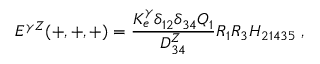Convert formula to latex. <formula><loc_0><loc_0><loc_500><loc_500>E ^ { \gamma Z } ( + , + , + ) = { \frac { K _ { e } ^ { \gamma } \delta _ { 1 2 } \delta _ { 3 4 } Q _ { 1 } } { D _ { 3 4 } ^ { Z } } } R _ { 1 } R _ { 3 } H _ { 2 1 4 3 5 } \, ,</formula> 